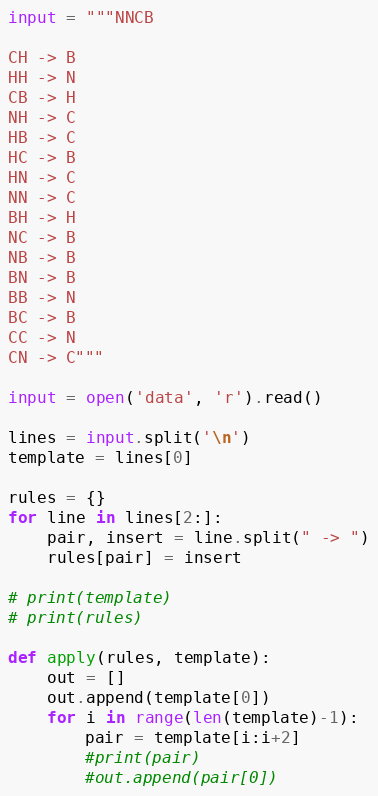<code> <loc_0><loc_0><loc_500><loc_500><_Python_>input = """NNCB

CH -> B
HH -> N
CB -> H
NH -> C
HB -> C
HC -> B
HN -> C
NN -> C
BH -> H
NC -> B
NB -> B
BN -> B
BB -> N
BC -> B
CC -> N
CN -> C"""

input = open('data', 'r').read()

lines = input.split('\n')
template = lines[0]

rules = {}
for line in lines[2:]:
    pair, insert = line.split(" -> ")
    rules[pair] = insert

# print(template)
# print(rules)

def apply(rules, template):
    out = []
    out.append(template[0])
    for i in range(len(template)-1):
        pair = template[i:i+2]
        #print(pair)
        #out.append(pair[0])</code> 